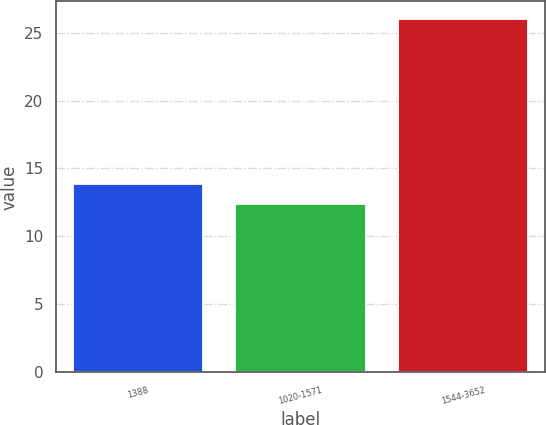Convert chart. <chart><loc_0><loc_0><loc_500><loc_500><bar_chart><fcel>1388<fcel>1020-1571<fcel>1544-3652<nl><fcel>13.88<fcel>12.4<fcel>26<nl></chart> 